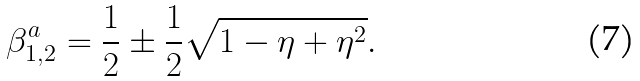Convert formula to latex. <formula><loc_0><loc_0><loc_500><loc_500>\beta _ { 1 , 2 } ^ { a } = \frac { 1 } { 2 } \pm \frac { 1 } { 2 } \sqrt { 1 - \eta + \eta ^ { 2 } } .</formula> 